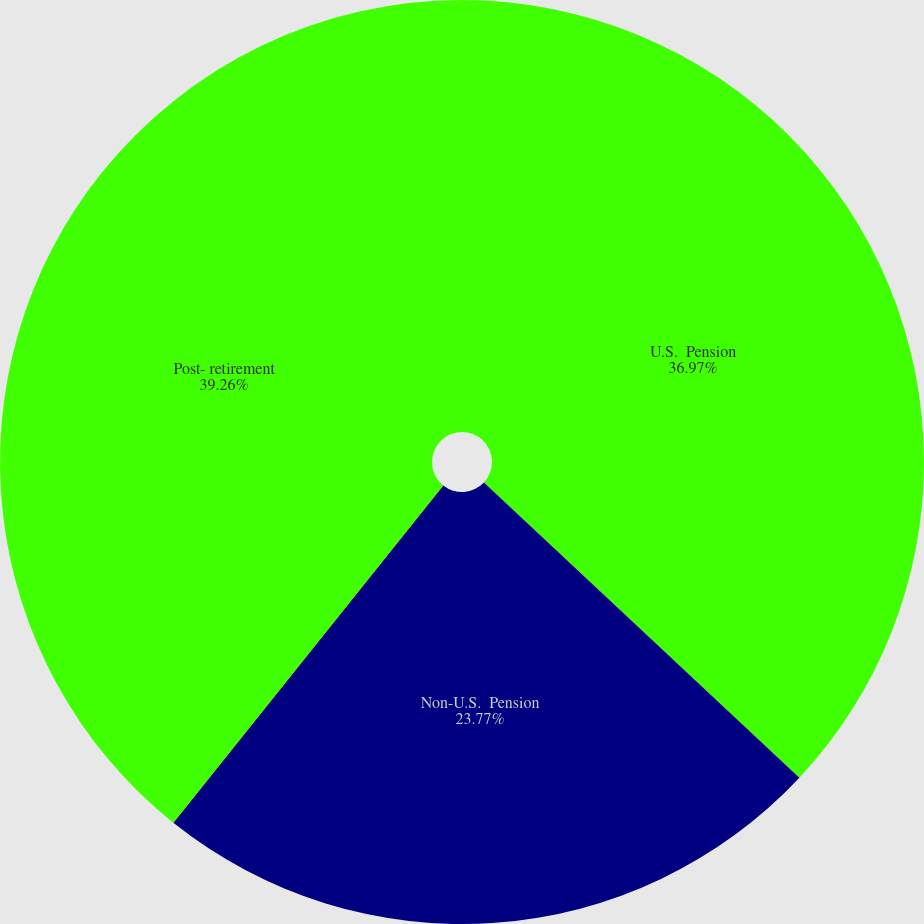<chart> <loc_0><loc_0><loc_500><loc_500><pie_chart><fcel>U.S.  Pension<fcel>Non-U.S.  Pension<fcel>Post- retirement<nl><fcel>36.97%<fcel>23.77%<fcel>39.26%<nl></chart> 